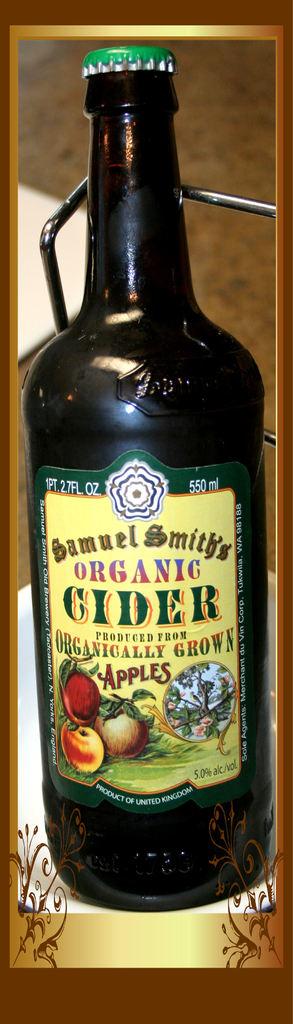What kind of cider is this?
Provide a short and direct response. Organic. How many ml is this bottle?
Make the answer very short. 550. 